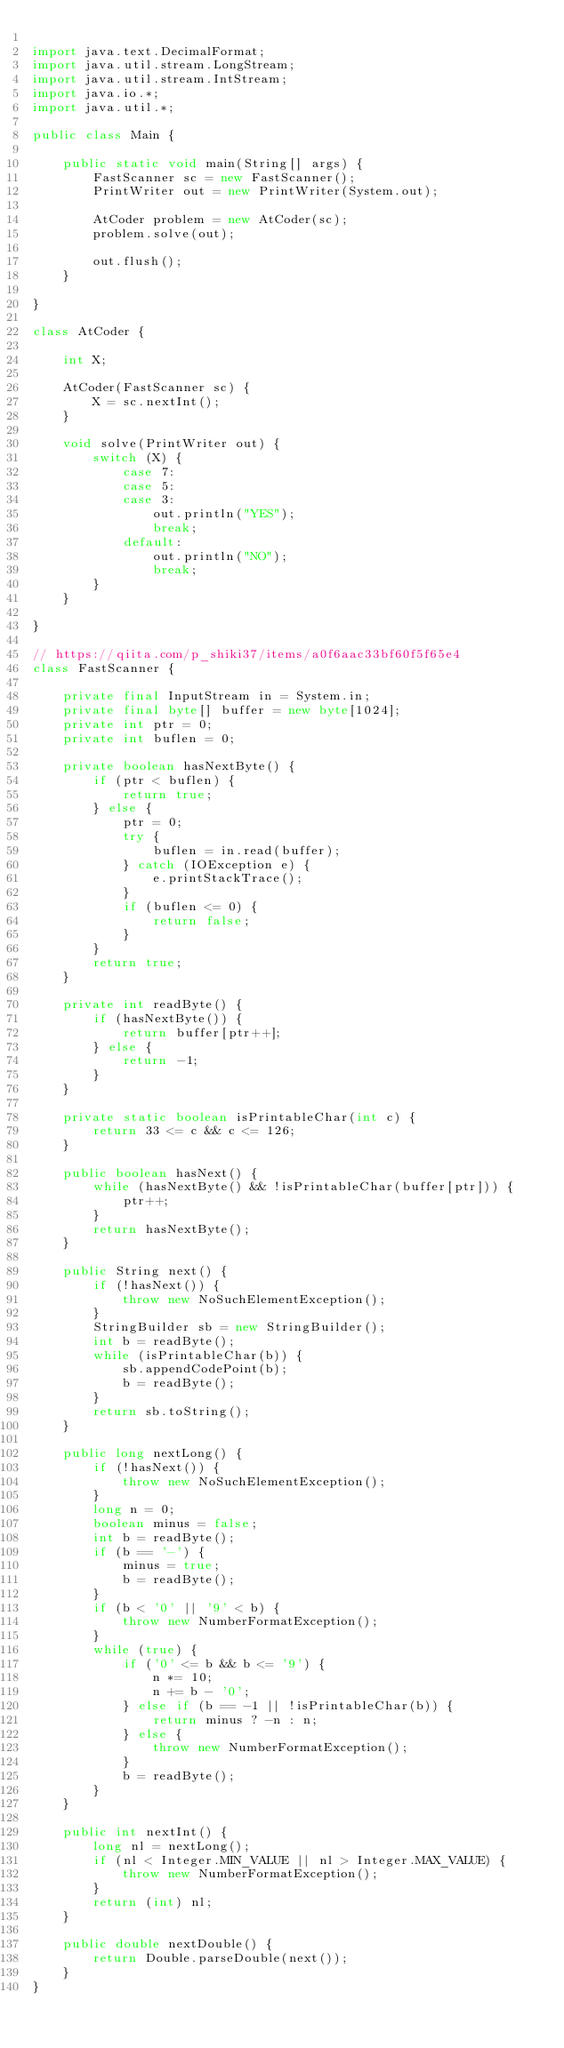Convert code to text. <code><loc_0><loc_0><loc_500><loc_500><_Java_>
import java.text.DecimalFormat;
import java.util.stream.LongStream;
import java.util.stream.IntStream;
import java.io.*;
import java.util.*;

public class Main {

    public static void main(String[] args) {
        FastScanner sc = new FastScanner();
        PrintWriter out = new PrintWriter(System.out);

        AtCoder problem = new AtCoder(sc);
        problem.solve(out);

        out.flush();
    }

}

class AtCoder {

    int X;

    AtCoder(FastScanner sc) {
        X = sc.nextInt();
    }

    void solve(PrintWriter out) {
        switch (X) {
            case 7:
            case 5:
            case 3:
                out.println("YES");
                break;
            default:
                out.println("NO");
                break;
        }
    }

}

// https://qiita.com/p_shiki37/items/a0f6aac33bf60f5f65e4
class FastScanner {

    private final InputStream in = System.in;
    private final byte[] buffer = new byte[1024];
    private int ptr = 0;
    private int buflen = 0;

    private boolean hasNextByte() {
        if (ptr < buflen) {
            return true;
        } else {
            ptr = 0;
            try {
                buflen = in.read(buffer);
            } catch (IOException e) {
                e.printStackTrace();
            }
            if (buflen <= 0) {
                return false;
            }
        }
        return true;
    }

    private int readByte() {
        if (hasNextByte()) {
            return buffer[ptr++];
        } else {
            return -1;
        }
    }

    private static boolean isPrintableChar(int c) {
        return 33 <= c && c <= 126;
    }

    public boolean hasNext() {
        while (hasNextByte() && !isPrintableChar(buffer[ptr])) {
            ptr++;
        }
        return hasNextByte();
    }

    public String next() {
        if (!hasNext()) {
            throw new NoSuchElementException();
        }
        StringBuilder sb = new StringBuilder();
        int b = readByte();
        while (isPrintableChar(b)) {
            sb.appendCodePoint(b);
            b = readByte();
        }
        return sb.toString();
    }

    public long nextLong() {
        if (!hasNext()) {
            throw new NoSuchElementException();
        }
        long n = 0;
        boolean minus = false;
        int b = readByte();
        if (b == '-') {
            minus = true;
            b = readByte();
        }
        if (b < '0' || '9' < b) {
            throw new NumberFormatException();
        }
        while (true) {
            if ('0' <= b && b <= '9') {
                n *= 10;
                n += b - '0';
            } else if (b == -1 || !isPrintableChar(b)) {
                return minus ? -n : n;
            } else {
                throw new NumberFormatException();
            }
            b = readByte();
        }
    }

    public int nextInt() {
        long nl = nextLong();
        if (nl < Integer.MIN_VALUE || nl > Integer.MAX_VALUE) {
            throw new NumberFormatException();
        }
        return (int) nl;
    }

    public double nextDouble() {
        return Double.parseDouble(next());
    }
}
</code> 